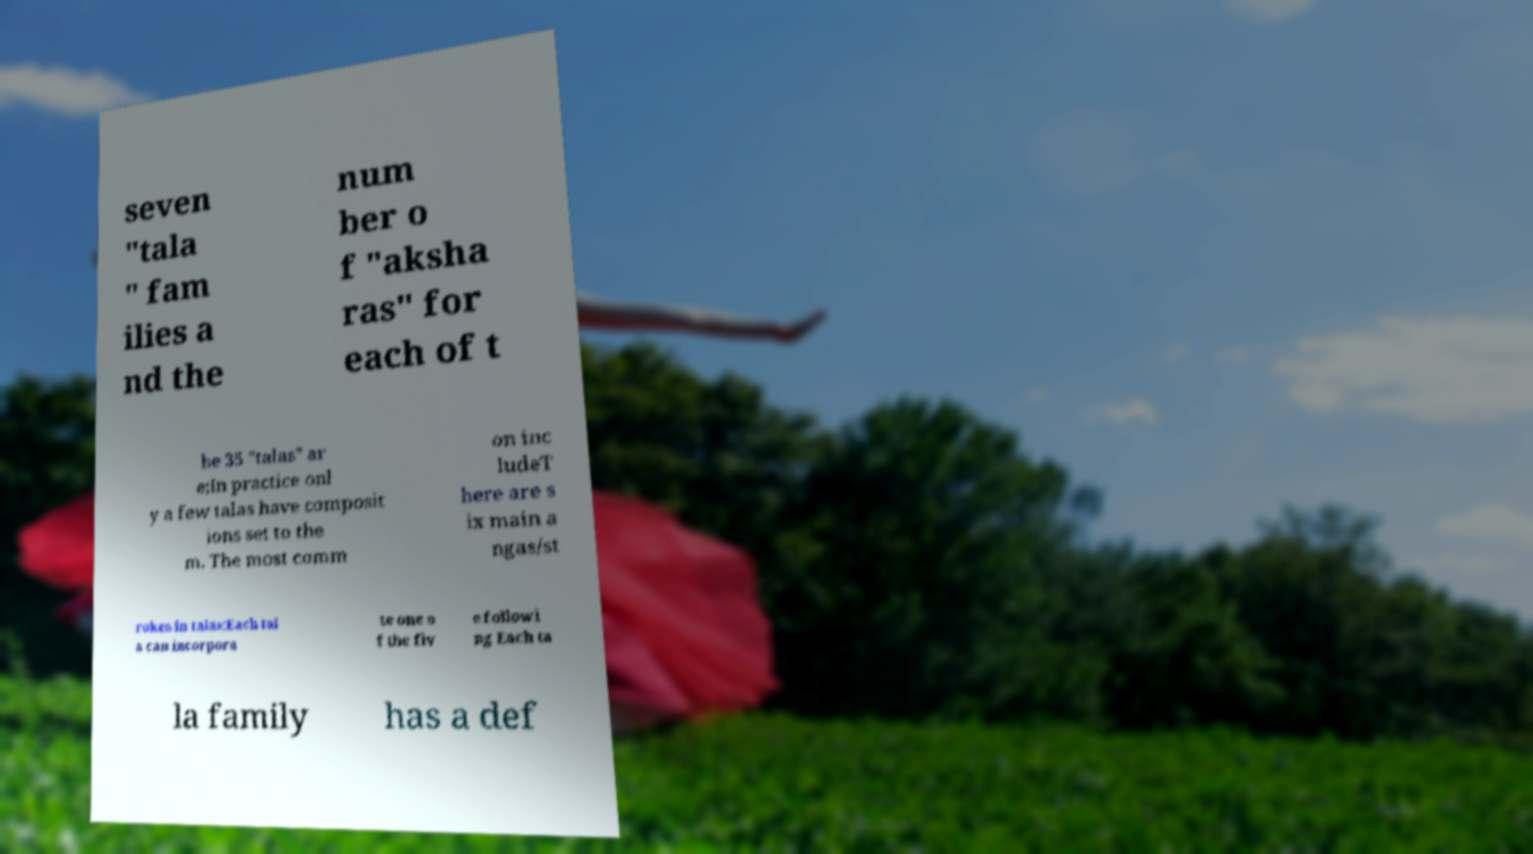I need the written content from this picture converted into text. Can you do that? seven "tala " fam ilies a nd the num ber o f "aksha ras" for each of t he 35 "talas" ar e;In practice onl y a few talas have composit ions set to the m. The most comm on inc ludeT here are s ix main a ngas/st rokes in talas;Each tal a can incorpora te one o f the fiv e followi ng Each ta la family has a def 